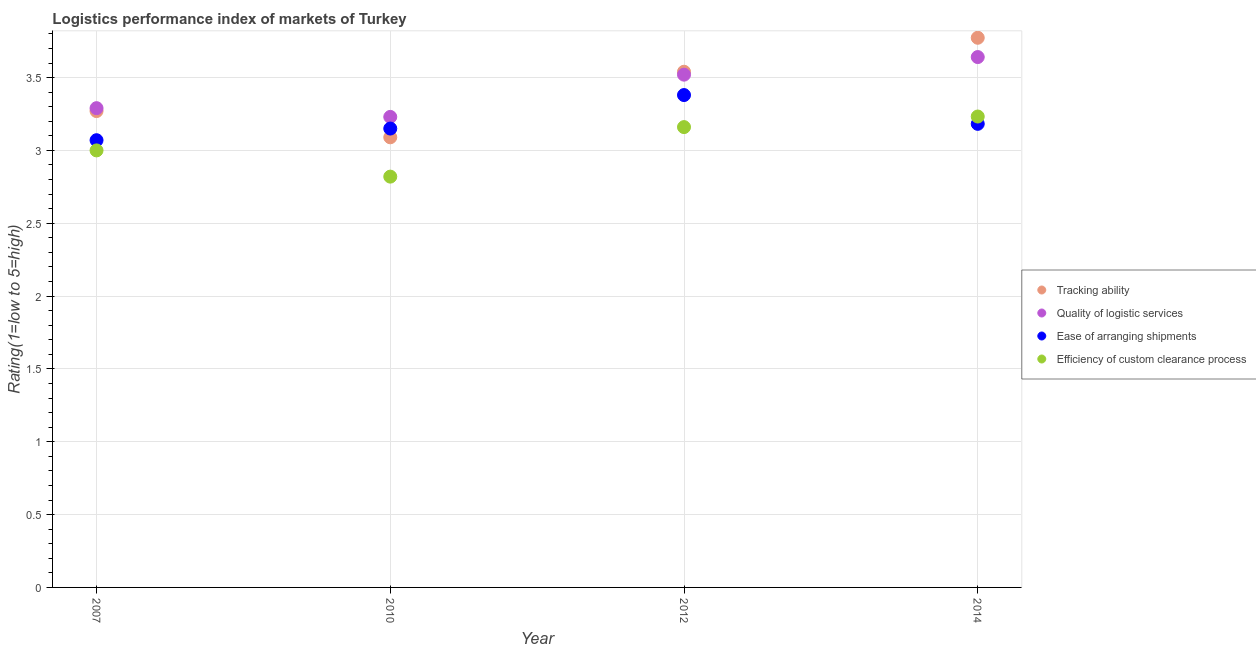How many different coloured dotlines are there?
Offer a very short reply. 4. What is the lpi rating of ease of arranging shipments in 2012?
Provide a succinct answer. 3.38. Across all years, what is the maximum lpi rating of tracking ability?
Your answer should be compact. 3.77. Across all years, what is the minimum lpi rating of ease of arranging shipments?
Offer a terse response. 3.07. What is the total lpi rating of ease of arranging shipments in the graph?
Offer a terse response. 12.78. What is the difference between the lpi rating of tracking ability in 2012 and that in 2014?
Ensure brevity in your answer.  -0.23. What is the difference between the lpi rating of efficiency of custom clearance process in 2010 and the lpi rating of quality of logistic services in 2012?
Give a very brief answer. -0.7. What is the average lpi rating of quality of logistic services per year?
Offer a very short reply. 3.42. In the year 2007, what is the difference between the lpi rating of efficiency of custom clearance process and lpi rating of tracking ability?
Your response must be concise. -0.27. What is the ratio of the lpi rating of tracking ability in 2007 to that in 2010?
Ensure brevity in your answer.  1.06. What is the difference between the highest and the second highest lpi rating of ease of arranging shipments?
Keep it short and to the point. 0.2. What is the difference between the highest and the lowest lpi rating of ease of arranging shipments?
Offer a very short reply. 0.31. Is the sum of the lpi rating of efficiency of custom clearance process in 2012 and 2014 greater than the maximum lpi rating of tracking ability across all years?
Make the answer very short. Yes. Is it the case that in every year, the sum of the lpi rating of tracking ability and lpi rating of quality of logistic services is greater than the lpi rating of ease of arranging shipments?
Your answer should be compact. Yes. Is the lpi rating of efficiency of custom clearance process strictly greater than the lpi rating of tracking ability over the years?
Keep it short and to the point. No. Is the lpi rating of quality of logistic services strictly less than the lpi rating of tracking ability over the years?
Your answer should be very brief. No. What is the difference between two consecutive major ticks on the Y-axis?
Offer a very short reply. 0.5. Are the values on the major ticks of Y-axis written in scientific E-notation?
Your answer should be compact. No. Does the graph contain grids?
Offer a very short reply. Yes. How many legend labels are there?
Keep it short and to the point. 4. How are the legend labels stacked?
Your answer should be compact. Vertical. What is the title of the graph?
Make the answer very short. Logistics performance index of markets of Turkey. Does "Miscellaneous expenses" appear as one of the legend labels in the graph?
Offer a very short reply. No. What is the label or title of the Y-axis?
Ensure brevity in your answer.  Rating(1=low to 5=high). What is the Rating(1=low to 5=high) in Tracking ability in 2007?
Keep it short and to the point. 3.27. What is the Rating(1=low to 5=high) of Quality of logistic services in 2007?
Your answer should be very brief. 3.29. What is the Rating(1=low to 5=high) of Ease of arranging shipments in 2007?
Make the answer very short. 3.07. What is the Rating(1=low to 5=high) in Efficiency of custom clearance process in 2007?
Give a very brief answer. 3. What is the Rating(1=low to 5=high) of Tracking ability in 2010?
Offer a very short reply. 3.09. What is the Rating(1=low to 5=high) of Quality of logistic services in 2010?
Make the answer very short. 3.23. What is the Rating(1=low to 5=high) of Ease of arranging shipments in 2010?
Ensure brevity in your answer.  3.15. What is the Rating(1=low to 5=high) of Efficiency of custom clearance process in 2010?
Offer a terse response. 2.82. What is the Rating(1=low to 5=high) in Tracking ability in 2012?
Keep it short and to the point. 3.54. What is the Rating(1=low to 5=high) of Quality of logistic services in 2012?
Your answer should be very brief. 3.52. What is the Rating(1=low to 5=high) in Ease of arranging shipments in 2012?
Ensure brevity in your answer.  3.38. What is the Rating(1=low to 5=high) of Efficiency of custom clearance process in 2012?
Provide a succinct answer. 3.16. What is the Rating(1=low to 5=high) in Tracking ability in 2014?
Ensure brevity in your answer.  3.77. What is the Rating(1=low to 5=high) in Quality of logistic services in 2014?
Offer a terse response. 3.64. What is the Rating(1=low to 5=high) of Ease of arranging shipments in 2014?
Make the answer very short. 3.18. What is the Rating(1=low to 5=high) of Efficiency of custom clearance process in 2014?
Your answer should be very brief. 3.23. Across all years, what is the maximum Rating(1=low to 5=high) in Tracking ability?
Your answer should be very brief. 3.77. Across all years, what is the maximum Rating(1=low to 5=high) of Quality of logistic services?
Offer a very short reply. 3.64. Across all years, what is the maximum Rating(1=low to 5=high) of Ease of arranging shipments?
Provide a short and direct response. 3.38. Across all years, what is the maximum Rating(1=low to 5=high) of Efficiency of custom clearance process?
Ensure brevity in your answer.  3.23. Across all years, what is the minimum Rating(1=low to 5=high) of Tracking ability?
Offer a terse response. 3.09. Across all years, what is the minimum Rating(1=low to 5=high) of Quality of logistic services?
Keep it short and to the point. 3.23. Across all years, what is the minimum Rating(1=low to 5=high) of Ease of arranging shipments?
Provide a succinct answer. 3.07. Across all years, what is the minimum Rating(1=low to 5=high) of Efficiency of custom clearance process?
Your response must be concise. 2.82. What is the total Rating(1=low to 5=high) of Tracking ability in the graph?
Provide a short and direct response. 13.67. What is the total Rating(1=low to 5=high) of Quality of logistic services in the graph?
Your response must be concise. 13.68. What is the total Rating(1=low to 5=high) in Ease of arranging shipments in the graph?
Offer a very short reply. 12.78. What is the total Rating(1=low to 5=high) of Efficiency of custom clearance process in the graph?
Ensure brevity in your answer.  12.21. What is the difference between the Rating(1=low to 5=high) of Tracking ability in 2007 and that in 2010?
Make the answer very short. 0.18. What is the difference between the Rating(1=low to 5=high) in Quality of logistic services in 2007 and that in 2010?
Make the answer very short. 0.06. What is the difference between the Rating(1=low to 5=high) of Ease of arranging shipments in 2007 and that in 2010?
Give a very brief answer. -0.08. What is the difference between the Rating(1=low to 5=high) in Efficiency of custom clearance process in 2007 and that in 2010?
Offer a very short reply. 0.18. What is the difference between the Rating(1=low to 5=high) in Tracking ability in 2007 and that in 2012?
Give a very brief answer. -0.27. What is the difference between the Rating(1=low to 5=high) of Quality of logistic services in 2007 and that in 2012?
Provide a succinct answer. -0.23. What is the difference between the Rating(1=low to 5=high) in Ease of arranging shipments in 2007 and that in 2012?
Provide a succinct answer. -0.31. What is the difference between the Rating(1=low to 5=high) in Efficiency of custom clearance process in 2007 and that in 2012?
Keep it short and to the point. -0.16. What is the difference between the Rating(1=low to 5=high) of Tracking ability in 2007 and that in 2014?
Give a very brief answer. -0.5. What is the difference between the Rating(1=low to 5=high) in Quality of logistic services in 2007 and that in 2014?
Ensure brevity in your answer.  -0.35. What is the difference between the Rating(1=low to 5=high) in Ease of arranging shipments in 2007 and that in 2014?
Your answer should be very brief. -0.11. What is the difference between the Rating(1=low to 5=high) in Efficiency of custom clearance process in 2007 and that in 2014?
Provide a short and direct response. -0.23. What is the difference between the Rating(1=low to 5=high) of Tracking ability in 2010 and that in 2012?
Give a very brief answer. -0.45. What is the difference between the Rating(1=low to 5=high) of Quality of logistic services in 2010 and that in 2012?
Provide a succinct answer. -0.29. What is the difference between the Rating(1=low to 5=high) of Ease of arranging shipments in 2010 and that in 2012?
Offer a terse response. -0.23. What is the difference between the Rating(1=low to 5=high) in Efficiency of custom clearance process in 2010 and that in 2012?
Make the answer very short. -0.34. What is the difference between the Rating(1=low to 5=high) of Tracking ability in 2010 and that in 2014?
Provide a short and direct response. -0.68. What is the difference between the Rating(1=low to 5=high) of Quality of logistic services in 2010 and that in 2014?
Make the answer very short. -0.41. What is the difference between the Rating(1=low to 5=high) in Ease of arranging shipments in 2010 and that in 2014?
Offer a terse response. -0.03. What is the difference between the Rating(1=low to 5=high) in Efficiency of custom clearance process in 2010 and that in 2014?
Give a very brief answer. -0.41. What is the difference between the Rating(1=low to 5=high) of Tracking ability in 2012 and that in 2014?
Provide a short and direct response. -0.23. What is the difference between the Rating(1=low to 5=high) in Quality of logistic services in 2012 and that in 2014?
Keep it short and to the point. -0.12. What is the difference between the Rating(1=low to 5=high) of Ease of arranging shipments in 2012 and that in 2014?
Make the answer very short. 0.2. What is the difference between the Rating(1=low to 5=high) of Efficiency of custom clearance process in 2012 and that in 2014?
Your answer should be very brief. -0.07. What is the difference between the Rating(1=low to 5=high) in Tracking ability in 2007 and the Rating(1=low to 5=high) in Ease of arranging shipments in 2010?
Provide a short and direct response. 0.12. What is the difference between the Rating(1=low to 5=high) of Tracking ability in 2007 and the Rating(1=low to 5=high) of Efficiency of custom clearance process in 2010?
Offer a terse response. 0.45. What is the difference between the Rating(1=low to 5=high) of Quality of logistic services in 2007 and the Rating(1=low to 5=high) of Ease of arranging shipments in 2010?
Ensure brevity in your answer.  0.14. What is the difference between the Rating(1=low to 5=high) of Quality of logistic services in 2007 and the Rating(1=low to 5=high) of Efficiency of custom clearance process in 2010?
Give a very brief answer. 0.47. What is the difference between the Rating(1=low to 5=high) in Tracking ability in 2007 and the Rating(1=low to 5=high) in Quality of logistic services in 2012?
Your answer should be very brief. -0.25. What is the difference between the Rating(1=low to 5=high) in Tracking ability in 2007 and the Rating(1=low to 5=high) in Ease of arranging shipments in 2012?
Offer a terse response. -0.11. What is the difference between the Rating(1=low to 5=high) of Tracking ability in 2007 and the Rating(1=low to 5=high) of Efficiency of custom clearance process in 2012?
Keep it short and to the point. 0.11. What is the difference between the Rating(1=low to 5=high) of Quality of logistic services in 2007 and the Rating(1=low to 5=high) of Ease of arranging shipments in 2012?
Offer a very short reply. -0.09. What is the difference between the Rating(1=low to 5=high) of Quality of logistic services in 2007 and the Rating(1=low to 5=high) of Efficiency of custom clearance process in 2012?
Provide a succinct answer. 0.13. What is the difference between the Rating(1=low to 5=high) of Ease of arranging shipments in 2007 and the Rating(1=low to 5=high) of Efficiency of custom clearance process in 2012?
Keep it short and to the point. -0.09. What is the difference between the Rating(1=low to 5=high) of Tracking ability in 2007 and the Rating(1=low to 5=high) of Quality of logistic services in 2014?
Your answer should be very brief. -0.37. What is the difference between the Rating(1=low to 5=high) of Tracking ability in 2007 and the Rating(1=low to 5=high) of Ease of arranging shipments in 2014?
Your answer should be compact. 0.09. What is the difference between the Rating(1=low to 5=high) in Tracking ability in 2007 and the Rating(1=low to 5=high) in Efficiency of custom clearance process in 2014?
Give a very brief answer. 0.04. What is the difference between the Rating(1=low to 5=high) in Quality of logistic services in 2007 and the Rating(1=low to 5=high) in Ease of arranging shipments in 2014?
Give a very brief answer. 0.11. What is the difference between the Rating(1=low to 5=high) of Quality of logistic services in 2007 and the Rating(1=low to 5=high) of Efficiency of custom clearance process in 2014?
Ensure brevity in your answer.  0.06. What is the difference between the Rating(1=low to 5=high) of Ease of arranging shipments in 2007 and the Rating(1=low to 5=high) of Efficiency of custom clearance process in 2014?
Make the answer very short. -0.16. What is the difference between the Rating(1=low to 5=high) of Tracking ability in 2010 and the Rating(1=low to 5=high) of Quality of logistic services in 2012?
Provide a succinct answer. -0.43. What is the difference between the Rating(1=low to 5=high) of Tracking ability in 2010 and the Rating(1=low to 5=high) of Ease of arranging shipments in 2012?
Your answer should be compact. -0.29. What is the difference between the Rating(1=low to 5=high) of Tracking ability in 2010 and the Rating(1=low to 5=high) of Efficiency of custom clearance process in 2012?
Offer a terse response. -0.07. What is the difference between the Rating(1=low to 5=high) in Quality of logistic services in 2010 and the Rating(1=low to 5=high) in Efficiency of custom clearance process in 2012?
Ensure brevity in your answer.  0.07. What is the difference between the Rating(1=low to 5=high) in Ease of arranging shipments in 2010 and the Rating(1=low to 5=high) in Efficiency of custom clearance process in 2012?
Offer a very short reply. -0.01. What is the difference between the Rating(1=low to 5=high) in Tracking ability in 2010 and the Rating(1=low to 5=high) in Quality of logistic services in 2014?
Your answer should be very brief. -0.55. What is the difference between the Rating(1=low to 5=high) of Tracking ability in 2010 and the Rating(1=low to 5=high) of Ease of arranging shipments in 2014?
Provide a succinct answer. -0.09. What is the difference between the Rating(1=low to 5=high) in Tracking ability in 2010 and the Rating(1=low to 5=high) in Efficiency of custom clearance process in 2014?
Provide a succinct answer. -0.14. What is the difference between the Rating(1=low to 5=high) of Quality of logistic services in 2010 and the Rating(1=low to 5=high) of Ease of arranging shipments in 2014?
Your answer should be compact. 0.05. What is the difference between the Rating(1=low to 5=high) in Quality of logistic services in 2010 and the Rating(1=low to 5=high) in Efficiency of custom clearance process in 2014?
Make the answer very short. -0. What is the difference between the Rating(1=low to 5=high) in Ease of arranging shipments in 2010 and the Rating(1=low to 5=high) in Efficiency of custom clearance process in 2014?
Your answer should be very brief. -0.08. What is the difference between the Rating(1=low to 5=high) in Tracking ability in 2012 and the Rating(1=low to 5=high) in Quality of logistic services in 2014?
Provide a short and direct response. -0.1. What is the difference between the Rating(1=low to 5=high) of Tracking ability in 2012 and the Rating(1=low to 5=high) of Ease of arranging shipments in 2014?
Provide a succinct answer. 0.36. What is the difference between the Rating(1=low to 5=high) in Tracking ability in 2012 and the Rating(1=low to 5=high) in Efficiency of custom clearance process in 2014?
Ensure brevity in your answer.  0.31. What is the difference between the Rating(1=low to 5=high) of Quality of logistic services in 2012 and the Rating(1=low to 5=high) of Ease of arranging shipments in 2014?
Your answer should be very brief. 0.34. What is the difference between the Rating(1=low to 5=high) of Quality of logistic services in 2012 and the Rating(1=low to 5=high) of Efficiency of custom clearance process in 2014?
Make the answer very short. 0.29. What is the difference between the Rating(1=low to 5=high) in Ease of arranging shipments in 2012 and the Rating(1=low to 5=high) in Efficiency of custom clearance process in 2014?
Keep it short and to the point. 0.15. What is the average Rating(1=low to 5=high) in Tracking ability per year?
Make the answer very short. 3.42. What is the average Rating(1=low to 5=high) of Quality of logistic services per year?
Provide a succinct answer. 3.42. What is the average Rating(1=low to 5=high) in Ease of arranging shipments per year?
Your answer should be very brief. 3.2. What is the average Rating(1=low to 5=high) in Efficiency of custom clearance process per year?
Ensure brevity in your answer.  3.05. In the year 2007, what is the difference between the Rating(1=low to 5=high) in Tracking ability and Rating(1=low to 5=high) in Quality of logistic services?
Provide a short and direct response. -0.02. In the year 2007, what is the difference between the Rating(1=low to 5=high) of Tracking ability and Rating(1=low to 5=high) of Efficiency of custom clearance process?
Provide a succinct answer. 0.27. In the year 2007, what is the difference between the Rating(1=low to 5=high) in Quality of logistic services and Rating(1=low to 5=high) in Ease of arranging shipments?
Your answer should be very brief. 0.22. In the year 2007, what is the difference between the Rating(1=low to 5=high) in Quality of logistic services and Rating(1=low to 5=high) in Efficiency of custom clearance process?
Offer a terse response. 0.29. In the year 2007, what is the difference between the Rating(1=low to 5=high) of Ease of arranging shipments and Rating(1=low to 5=high) of Efficiency of custom clearance process?
Give a very brief answer. 0.07. In the year 2010, what is the difference between the Rating(1=low to 5=high) of Tracking ability and Rating(1=low to 5=high) of Quality of logistic services?
Your answer should be very brief. -0.14. In the year 2010, what is the difference between the Rating(1=low to 5=high) in Tracking ability and Rating(1=low to 5=high) in Ease of arranging shipments?
Your answer should be very brief. -0.06. In the year 2010, what is the difference between the Rating(1=low to 5=high) in Tracking ability and Rating(1=low to 5=high) in Efficiency of custom clearance process?
Make the answer very short. 0.27. In the year 2010, what is the difference between the Rating(1=low to 5=high) in Quality of logistic services and Rating(1=low to 5=high) in Efficiency of custom clearance process?
Keep it short and to the point. 0.41. In the year 2010, what is the difference between the Rating(1=low to 5=high) in Ease of arranging shipments and Rating(1=low to 5=high) in Efficiency of custom clearance process?
Provide a succinct answer. 0.33. In the year 2012, what is the difference between the Rating(1=low to 5=high) in Tracking ability and Rating(1=low to 5=high) in Quality of logistic services?
Give a very brief answer. 0.02. In the year 2012, what is the difference between the Rating(1=low to 5=high) of Tracking ability and Rating(1=low to 5=high) of Ease of arranging shipments?
Your response must be concise. 0.16. In the year 2012, what is the difference between the Rating(1=low to 5=high) of Tracking ability and Rating(1=low to 5=high) of Efficiency of custom clearance process?
Your answer should be very brief. 0.38. In the year 2012, what is the difference between the Rating(1=low to 5=high) in Quality of logistic services and Rating(1=low to 5=high) in Ease of arranging shipments?
Your response must be concise. 0.14. In the year 2012, what is the difference between the Rating(1=low to 5=high) in Quality of logistic services and Rating(1=low to 5=high) in Efficiency of custom clearance process?
Your response must be concise. 0.36. In the year 2012, what is the difference between the Rating(1=low to 5=high) in Ease of arranging shipments and Rating(1=low to 5=high) in Efficiency of custom clearance process?
Keep it short and to the point. 0.22. In the year 2014, what is the difference between the Rating(1=low to 5=high) of Tracking ability and Rating(1=low to 5=high) of Quality of logistic services?
Provide a short and direct response. 0.13. In the year 2014, what is the difference between the Rating(1=low to 5=high) of Tracking ability and Rating(1=low to 5=high) of Ease of arranging shipments?
Provide a short and direct response. 0.59. In the year 2014, what is the difference between the Rating(1=low to 5=high) in Tracking ability and Rating(1=low to 5=high) in Efficiency of custom clearance process?
Give a very brief answer. 0.54. In the year 2014, what is the difference between the Rating(1=low to 5=high) in Quality of logistic services and Rating(1=low to 5=high) in Ease of arranging shipments?
Provide a short and direct response. 0.46. In the year 2014, what is the difference between the Rating(1=low to 5=high) of Quality of logistic services and Rating(1=low to 5=high) of Efficiency of custom clearance process?
Ensure brevity in your answer.  0.41. In the year 2014, what is the difference between the Rating(1=low to 5=high) of Ease of arranging shipments and Rating(1=low to 5=high) of Efficiency of custom clearance process?
Keep it short and to the point. -0.05. What is the ratio of the Rating(1=low to 5=high) of Tracking ability in 2007 to that in 2010?
Ensure brevity in your answer.  1.06. What is the ratio of the Rating(1=low to 5=high) in Quality of logistic services in 2007 to that in 2010?
Your response must be concise. 1.02. What is the ratio of the Rating(1=low to 5=high) in Ease of arranging shipments in 2007 to that in 2010?
Provide a succinct answer. 0.97. What is the ratio of the Rating(1=low to 5=high) of Efficiency of custom clearance process in 2007 to that in 2010?
Your answer should be compact. 1.06. What is the ratio of the Rating(1=low to 5=high) in Tracking ability in 2007 to that in 2012?
Ensure brevity in your answer.  0.92. What is the ratio of the Rating(1=low to 5=high) of Quality of logistic services in 2007 to that in 2012?
Offer a terse response. 0.93. What is the ratio of the Rating(1=low to 5=high) in Ease of arranging shipments in 2007 to that in 2012?
Offer a very short reply. 0.91. What is the ratio of the Rating(1=low to 5=high) in Efficiency of custom clearance process in 2007 to that in 2012?
Make the answer very short. 0.95. What is the ratio of the Rating(1=low to 5=high) of Tracking ability in 2007 to that in 2014?
Your answer should be very brief. 0.87. What is the ratio of the Rating(1=low to 5=high) of Quality of logistic services in 2007 to that in 2014?
Ensure brevity in your answer.  0.9. What is the ratio of the Rating(1=low to 5=high) of Ease of arranging shipments in 2007 to that in 2014?
Offer a very short reply. 0.96. What is the ratio of the Rating(1=low to 5=high) in Efficiency of custom clearance process in 2007 to that in 2014?
Keep it short and to the point. 0.93. What is the ratio of the Rating(1=low to 5=high) of Tracking ability in 2010 to that in 2012?
Give a very brief answer. 0.87. What is the ratio of the Rating(1=low to 5=high) in Quality of logistic services in 2010 to that in 2012?
Make the answer very short. 0.92. What is the ratio of the Rating(1=low to 5=high) in Ease of arranging shipments in 2010 to that in 2012?
Your answer should be very brief. 0.93. What is the ratio of the Rating(1=low to 5=high) of Efficiency of custom clearance process in 2010 to that in 2012?
Your response must be concise. 0.89. What is the ratio of the Rating(1=low to 5=high) in Tracking ability in 2010 to that in 2014?
Your answer should be compact. 0.82. What is the ratio of the Rating(1=low to 5=high) in Quality of logistic services in 2010 to that in 2014?
Provide a short and direct response. 0.89. What is the ratio of the Rating(1=low to 5=high) of Efficiency of custom clearance process in 2010 to that in 2014?
Give a very brief answer. 0.87. What is the ratio of the Rating(1=low to 5=high) in Tracking ability in 2012 to that in 2014?
Your response must be concise. 0.94. What is the ratio of the Rating(1=low to 5=high) in Quality of logistic services in 2012 to that in 2014?
Keep it short and to the point. 0.97. What is the ratio of the Rating(1=low to 5=high) of Ease of arranging shipments in 2012 to that in 2014?
Your response must be concise. 1.06. What is the ratio of the Rating(1=low to 5=high) in Efficiency of custom clearance process in 2012 to that in 2014?
Ensure brevity in your answer.  0.98. What is the difference between the highest and the second highest Rating(1=low to 5=high) in Tracking ability?
Your answer should be very brief. 0.23. What is the difference between the highest and the second highest Rating(1=low to 5=high) in Quality of logistic services?
Offer a terse response. 0.12. What is the difference between the highest and the second highest Rating(1=low to 5=high) of Ease of arranging shipments?
Your response must be concise. 0.2. What is the difference between the highest and the second highest Rating(1=low to 5=high) of Efficiency of custom clearance process?
Offer a very short reply. 0.07. What is the difference between the highest and the lowest Rating(1=low to 5=high) in Tracking ability?
Keep it short and to the point. 0.68. What is the difference between the highest and the lowest Rating(1=low to 5=high) in Quality of logistic services?
Ensure brevity in your answer.  0.41. What is the difference between the highest and the lowest Rating(1=low to 5=high) of Ease of arranging shipments?
Your answer should be very brief. 0.31. What is the difference between the highest and the lowest Rating(1=low to 5=high) in Efficiency of custom clearance process?
Give a very brief answer. 0.41. 